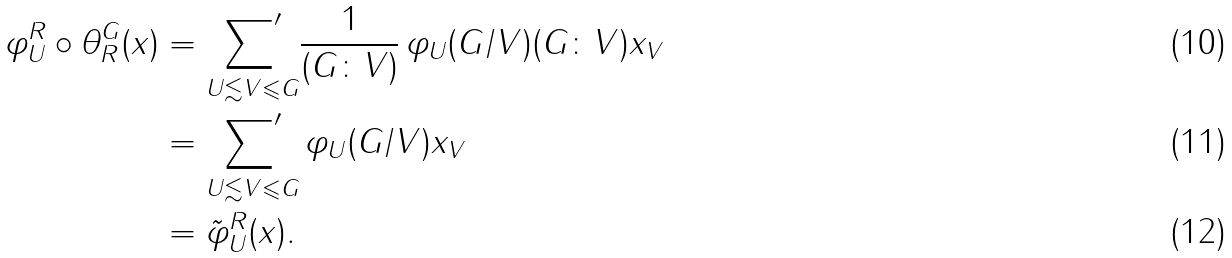<formula> <loc_0><loc_0><loc_500><loc_500>\varphi ^ { R } _ { U } \circ \theta _ { R } ^ { G } ( { x } ) & = \underset { U \lesssim V \leqslant G } { { \sum } ^ { \prime } } \frac { 1 } { ( G \colon V ) } \, \varphi _ { U } ( G / V ) ( G \colon V ) x _ { V } \\ & = \underset { U \lesssim V \leqslant G } { { \sum } ^ { \prime } } \, \varphi _ { U } ( G / V ) x _ { V } \\ & = \tilde { \varphi } ^ { R } _ { U } ( { x } ) .</formula> 